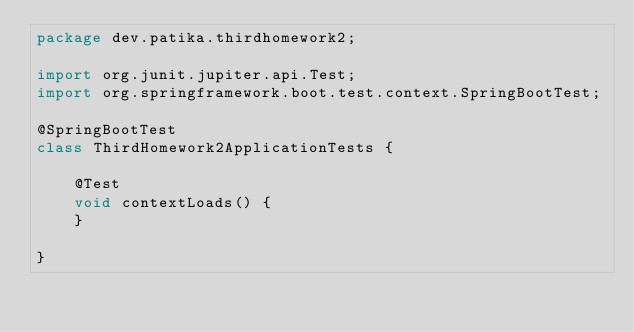<code> <loc_0><loc_0><loc_500><loc_500><_Java_>package dev.patika.thirdhomework2;

import org.junit.jupiter.api.Test;
import org.springframework.boot.test.context.SpringBootTest;

@SpringBootTest
class ThirdHomework2ApplicationTests {

    @Test
    void contextLoads() {
    }

}
</code> 